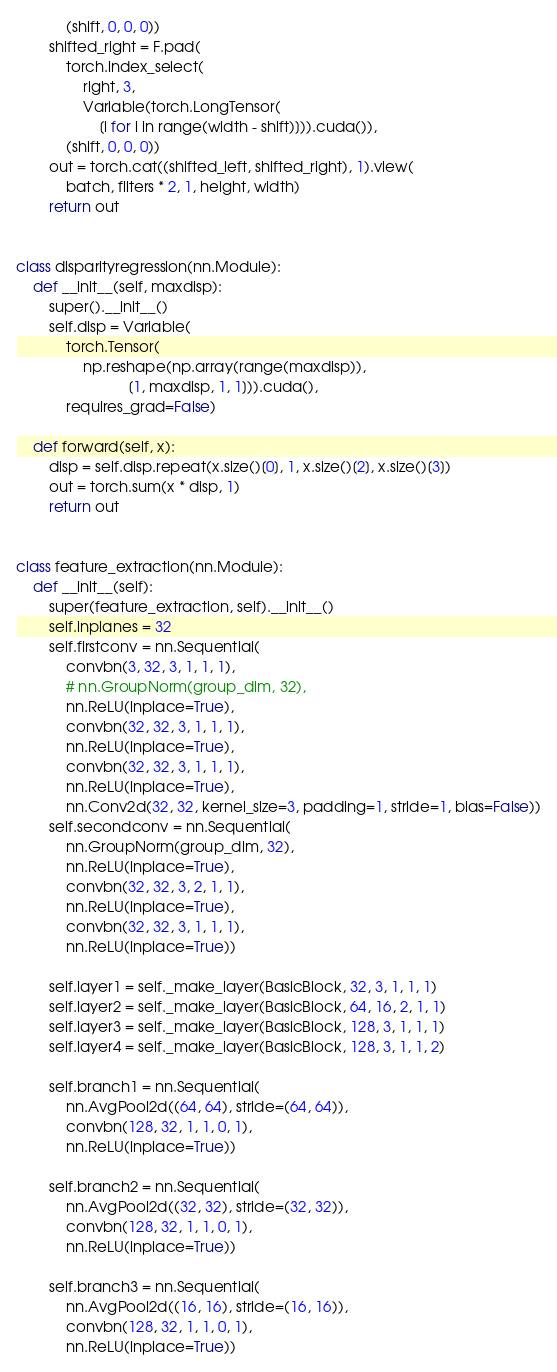<code> <loc_0><loc_0><loc_500><loc_500><_Python_>            (shift, 0, 0, 0))
        shifted_right = F.pad(
            torch.index_select(
                right, 3,
                Variable(torch.LongTensor(
                    [i for i in range(width - shift)])).cuda()),
            (shift, 0, 0, 0))
        out = torch.cat((shifted_left, shifted_right), 1).view(
            batch, filters * 2, 1, height, width)
        return out


class disparityregression(nn.Module):
    def __init__(self, maxdisp):
        super().__init__()
        self.disp = Variable(
            torch.Tensor(
                np.reshape(np.array(range(maxdisp)),
                           [1, maxdisp, 1, 1])).cuda(),
            requires_grad=False)

    def forward(self, x):
        disp = self.disp.repeat(x.size()[0], 1, x.size()[2], x.size()[3])
        out = torch.sum(x * disp, 1)
        return out


class feature_extraction(nn.Module):
    def __init__(self):
        super(feature_extraction, self).__init__()
        self.inplanes = 32
        self.firstconv = nn.Sequential(
            convbn(3, 32, 3, 1, 1, 1),
            # nn.GroupNorm(group_dim, 32),
            nn.ReLU(inplace=True),
            convbn(32, 32, 3, 1, 1, 1),
            nn.ReLU(inplace=True),
            convbn(32, 32, 3, 1, 1, 1),
            nn.ReLU(inplace=True),
            nn.Conv2d(32, 32, kernel_size=3, padding=1, stride=1, bias=False))
        self.secondconv = nn.Sequential(
            nn.GroupNorm(group_dim, 32),
            nn.ReLU(inplace=True),
            convbn(32, 32, 3, 2, 1, 1),
            nn.ReLU(inplace=True),
            convbn(32, 32, 3, 1, 1, 1),
            nn.ReLU(inplace=True))

        self.layer1 = self._make_layer(BasicBlock, 32, 3, 1, 1, 1)
        self.layer2 = self._make_layer(BasicBlock, 64, 16, 2, 1, 1)
        self.layer3 = self._make_layer(BasicBlock, 128, 3, 1, 1, 1)
        self.layer4 = self._make_layer(BasicBlock, 128, 3, 1, 1, 2)

        self.branch1 = nn.Sequential(
            nn.AvgPool2d((64, 64), stride=(64, 64)),
            convbn(128, 32, 1, 1, 0, 1),
            nn.ReLU(inplace=True))

        self.branch2 = nn.Sequential(
            nn.AvgPool2d((32, 32), stride=(32, 32)),
            convbn(128, 32, 1, 1, 0, 1),
            nn.ReLU(inplace=True))

        self.branch3 = nn.Sequential(
            nn.AvgPool2d((16, 16), stride=(16, 16)),
            convbn(128, 32, 1, 1, 0, 1),
            nn.ReLU(inplace=True))
</code> 